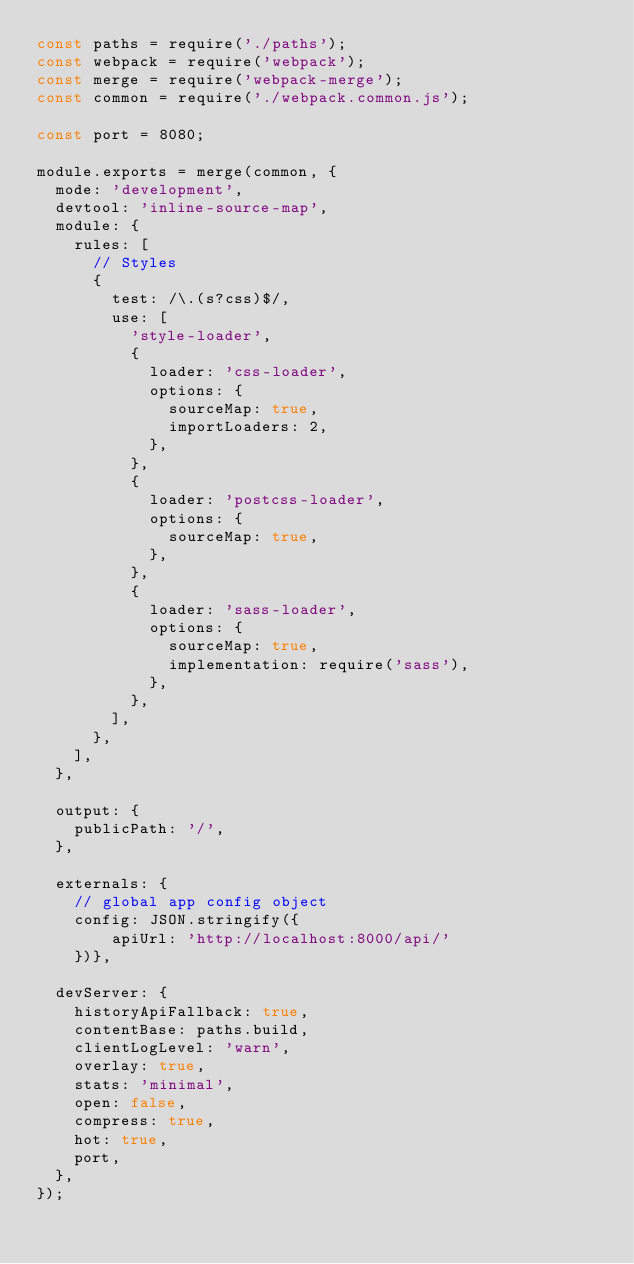<code> <loc_0><loc_0><loc_500><loc_500><_JavaScript_>const paths = require('./paths');
const webpack = require('webpack');
const merge = require('webpack-merge');
const common = require('./webpack.common.js');

const port = 8080;

module.exports = merge(common, {
  mode: 'development',
  devtool: 'inline-source-map',
  module: {
    rules: [
      // Styles
      {
        test: /\.(s?css)$/,
        use: [
          'style-loader',
          {
            loader: 'css-loader',
            options: {
              sourceMap: true,
              importLoaders: 2,
            },
          },
          {
            loader: 'postcss-loader',
            options: {
              sourceMap: true,
            },
          },
          {
            loader: 'sass-loader',
            options: {
              sourceMap: true,
              implementation: require('sass'),
            },
          },
        ],
      },
    ],
  },

  output: {
    publicPath: '/',
  },

  externals: {
    // global app config object
    config: JSON.stringify({
        apiUrl: 'http://localhost:8000/api/'
    })},

  devServer: {
    historyApiFallback: true,
    contentBase: paths.build,
    clientLogLevel: 'warn',
    overlay: true,
    stats: 'minimal',
    open: false,
    compress: true,
    hot: true,
    port,
  },
});
</code> 